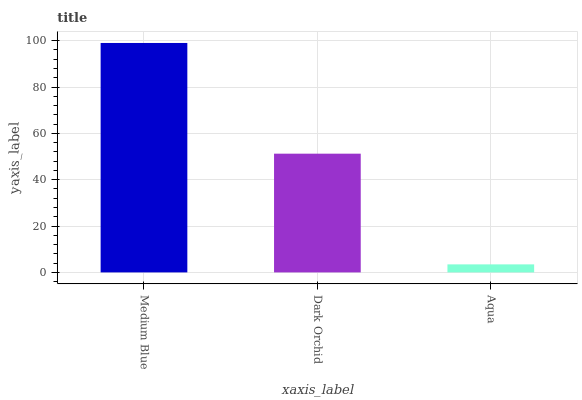Is Aqua the minimum?
Answer yes or no. Yes. Is Medium Blue the maximum?
Answer yes or no. Yes. Is Dark Orchid the minimum?
Answer yes or no. No. Is Dark Orchid the maximum?
Answer yes or no. No. Is Medium Blue greater than Dark Orchid?
Answer yes or no. Yes. Is Dark Orchid less than Medium Blue?
Answer yes or no. Yes. Is Dark Orchid greater than Medium Blue?
Answer yes or no. No. Is Medium Blue less than Dark Orchid?
Answer yes or no. No. Is Dark Orchid the high median?
Answer yes or no. Yes. Is Dark Orchid the low median?
Answer yes or no. Yes. Is Medium Blue the high median?
Answer yes or no. No. Is Medium Blue the low median?
Answer yes or no. No. 